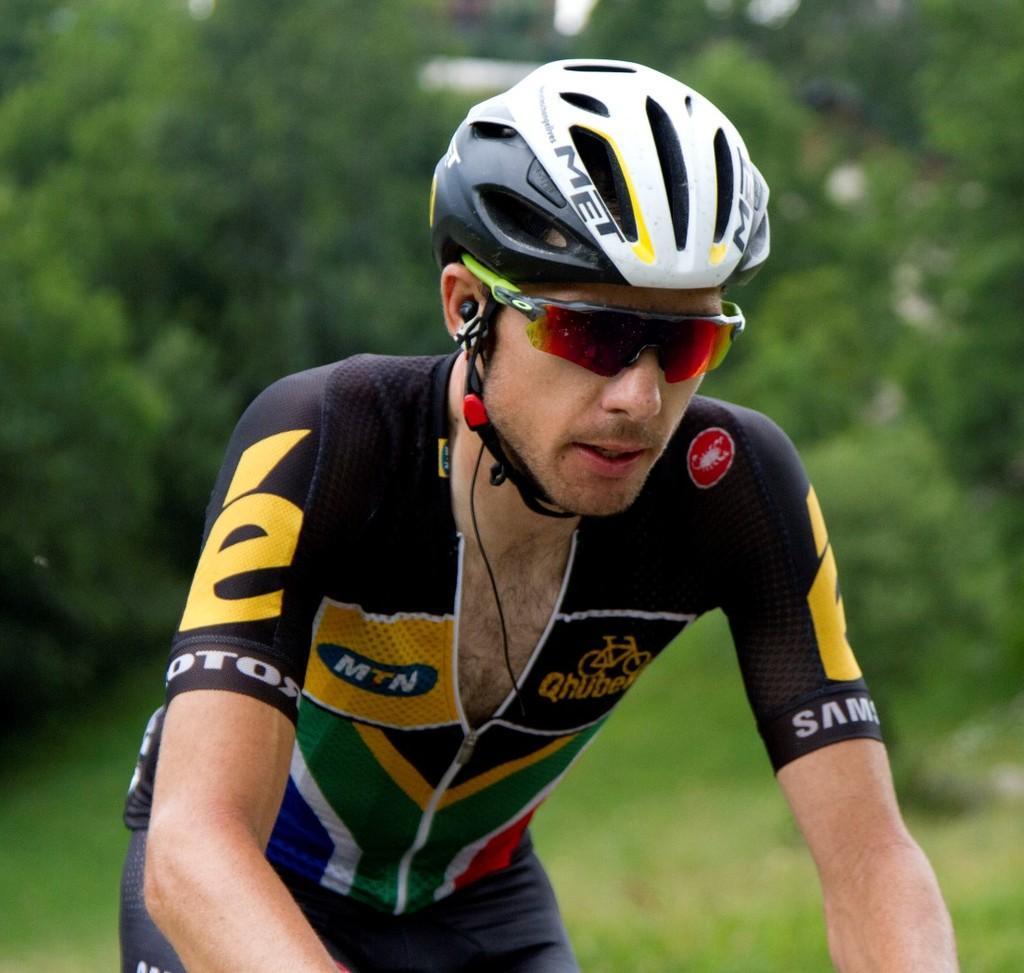Can you describe this image briefly? In this image there is a man, he is wearing a helmet, he is wearing goggles, there is a wire, at the background of the image there are trees. 